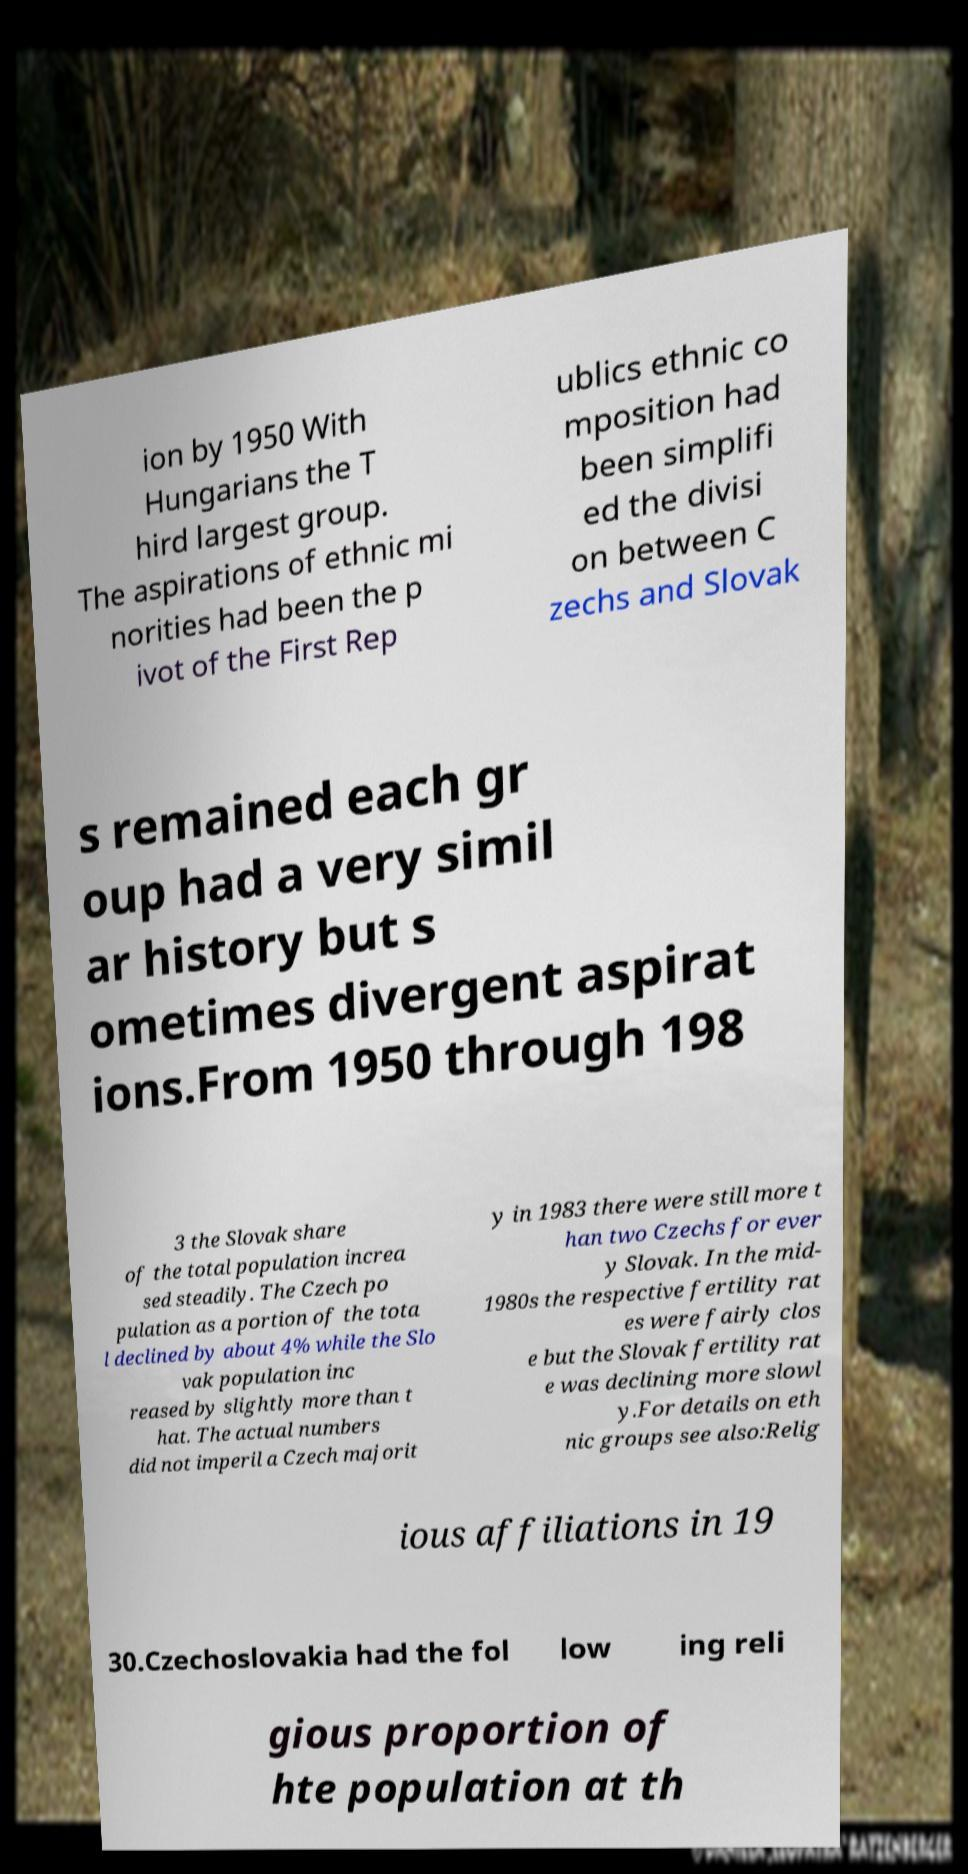I need the written content from this picture converted into text. Can you do that? ion by 1950 With Hungarians the T hird largest group. The aspirations of ethnic mi norities had been the p ivot of the First Rep ublics ethnic co mposition had been simplifi ed the divisi on between C zechs and Slovak s remained each gr oup had a very simil ar history but s ometimes divergent aspirat ions.From 1950 through 198 3 the Slovak share of the total population increa sed steadily. The Czech po pulation as a portion of the tota l declined by about 4% while the Slo vak population inc reased by slightly more than t hat. The actual numbers did not imperil a Czech majorit y in 1983 there were still more t han two Czechs for ever y Slovak. In the mid- 1980s the respective fertility rat es were fairly clos e but the Slovak fertility rat e was declining more slowl y.For details on eth nic groups see also:Relig ious affiliations in 19 30.Czechoslovakia had the fol low ing reli gious proportion of hte population at th 